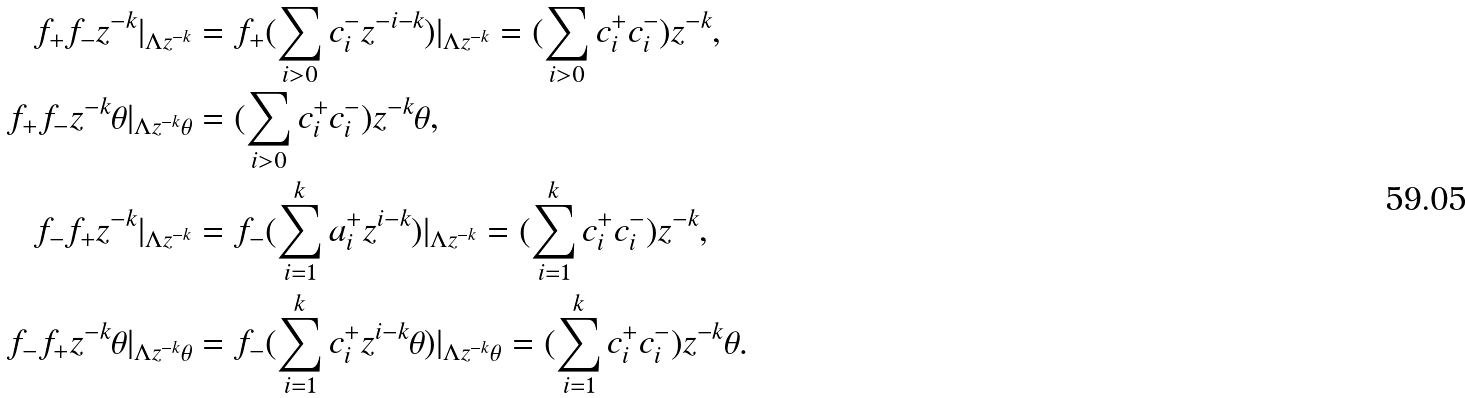Convert formula to latex. <formula><loc_0><loc_0><loc_500><loc_500>f _ { + } f _ { - } z ^ { - k } | _ { \Lambda z ^ { - k } } & = f _ { + } ( \sum _ { i > 0 } c _ { i } ^ { - } z ^ { - i - k } ) | _ { \Lambda z ^ { - k } } = ( \sum _ { i > 0 } c ^ { + } _ { i } c ^ { - } _ { i } ) z ^ { - k } , \\ f _ { + } f _ { - } z ^ { - k } \theta | _ { \Lambda z ^ { - k } \theta } & = ( \sum _ { i > 0 } c ^ { + } _ { i } c ^ { - } _ { i } ) z ^ { - k } \theta , \\ f _ { - } f _ { + } z ^ { - k } | _ { \Lambda z ^ { - k } } & = f _ { - } ( \sum _ { i = 1 } ^ { k } a _ { i } ^ { + } z ^ { i - k } ) | _ { \Lambda z ^ { - k } } = ( \sum _ { i = 1 } ^ { k } c ^ { + } _ { i } c ^ { - } _ { i } ) z ^ { - k } , \\ f _ { - } f _ { + } z ^ { - k } \theta | _ { \Lambda z ^ { - k } \theta } & = f _ { - } ( \sum _ { i = 1 } ^ { k } c _ { i } ^ { + } z ^ { i - k } \theta ) | _ { \Lambda z ^ { - k } \theta } = ( \sum _ { i = 1 } ^ { k } c ^ { + } _ { i } c ^ { - } _ { i } ) z ^ { - k } \theta .</formula> 